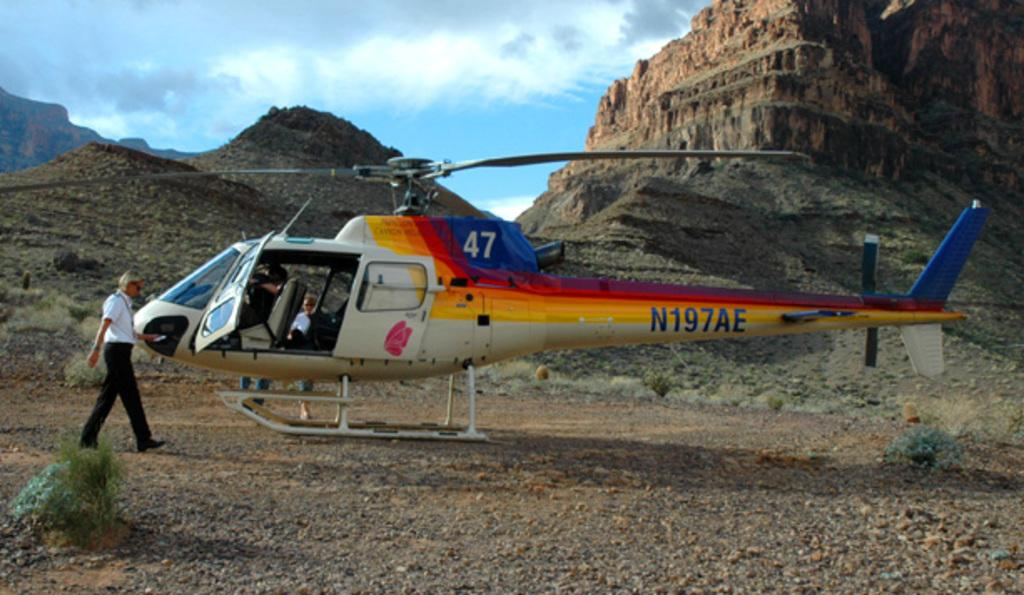<image>
Summarize the visual content of the image. Helicopter number 47 has landed among rocky cliffs. 